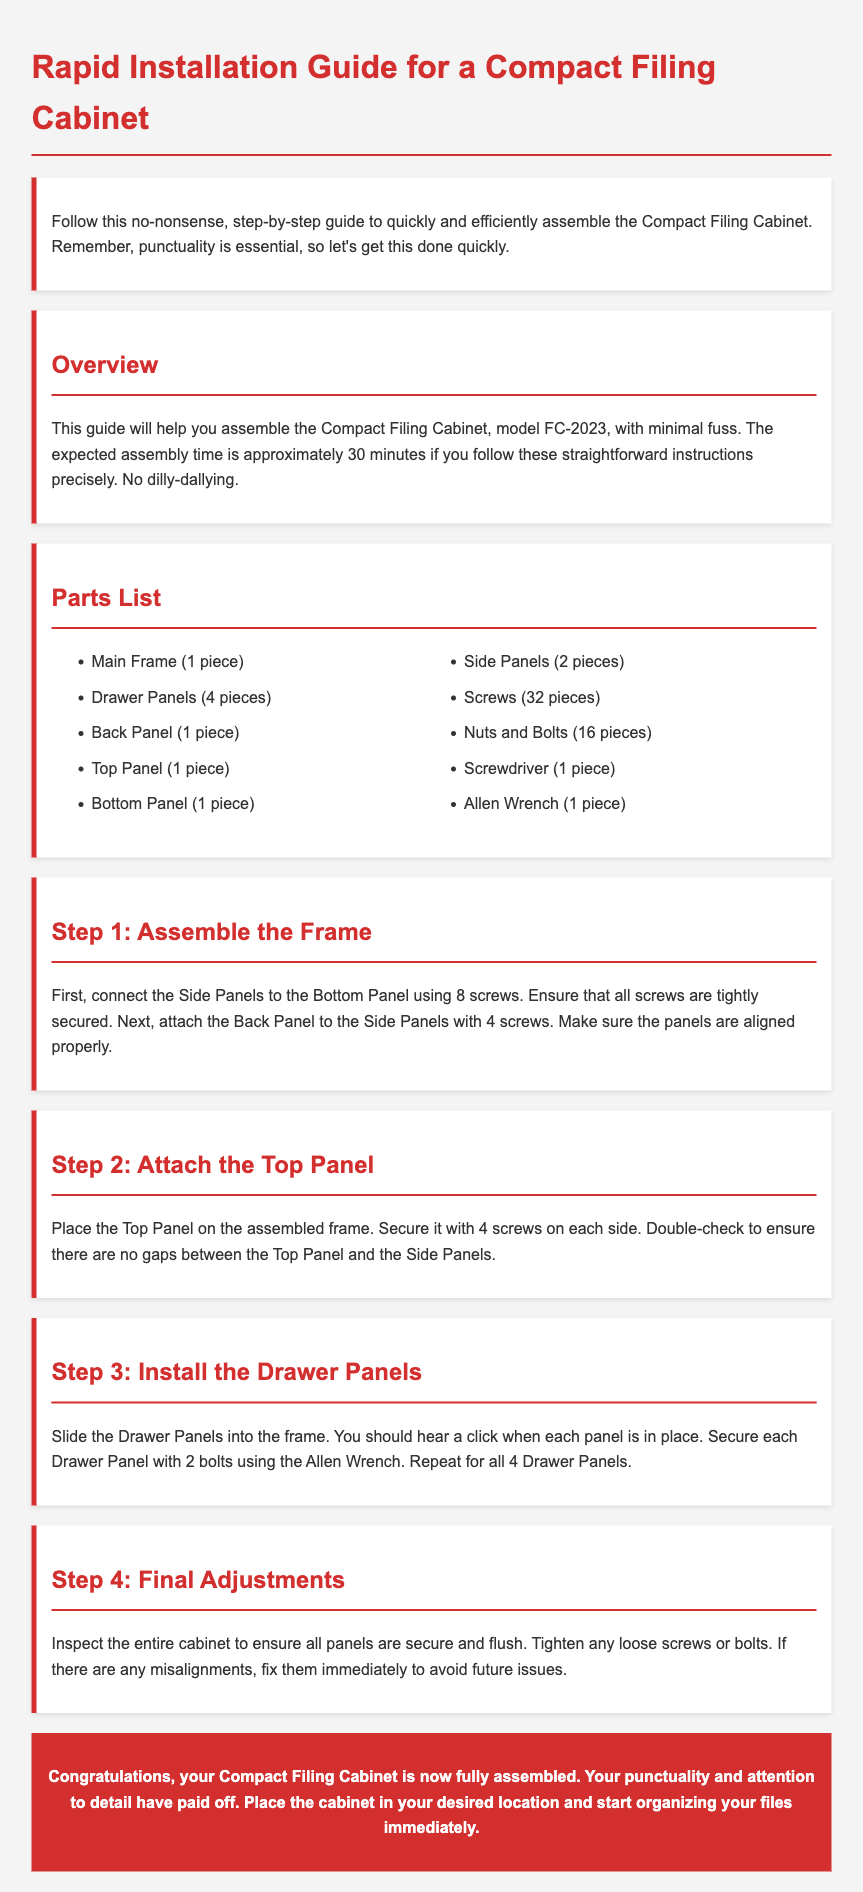What is the model number of the cabinet? The model number of the Compact Filing Cabinet is explicitly stated in the overview section.
Answer: FC-2023 How long is the expected assembly time? The document specifically mentions the expected assembly time for the Compact Filing Cabinet.
Answer: 30 minutes What is the quantity of screws included? The parts list section details the components and their quantities, including screws.
Answer: 32 pieces What step involves securing the Drawer Panels? The instruction specifies the action taken regarding Drawer Panels, indicating where they are installed in the process.
Answer: Install the Drawer Panels How many Drawer Panels need to be secured? The document states the number of Drawer Panels that require securing during assembly.
Answer: 4 Drawer Panels What tool is suggested for securing the Drawer Panels? The assembly instructions mention a specific tool used to secure the Drawer Panels.
Answer: Allen Wrench What is the first action to take in step 1? The first action in the assembly process is clearly defined in the initial step of the document.
Answer: Connect the Side Panels What color is the section title for "Overview"? The style chosen for section titles, including "Overview," determines the color used.
Answer: Red What should be done if there are misalignments? The document provides guidance on actions to take in case of any assembly discrepancies.
Answer: Fix them immediately 